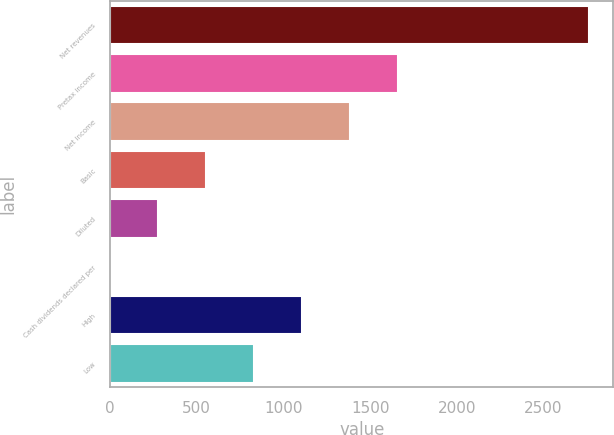Convert chart to OTSL. <chart><loc_0><loc_0><loc_500><loc_500><bar_chart><fcel>Net revenues<fcel>Pretax income<fcel>Net income<fcel>Basic<fcel>Diluted<fcel>Cash dividends declared per<fcel>High<fcel>Low<nl><fcel>2765<fcel>1659.25<fcel>1382.82<fcel>553.53<fcel>277.1<fcel>0.67<fcel>1106.39<fcel>829.96<nl></chart> 